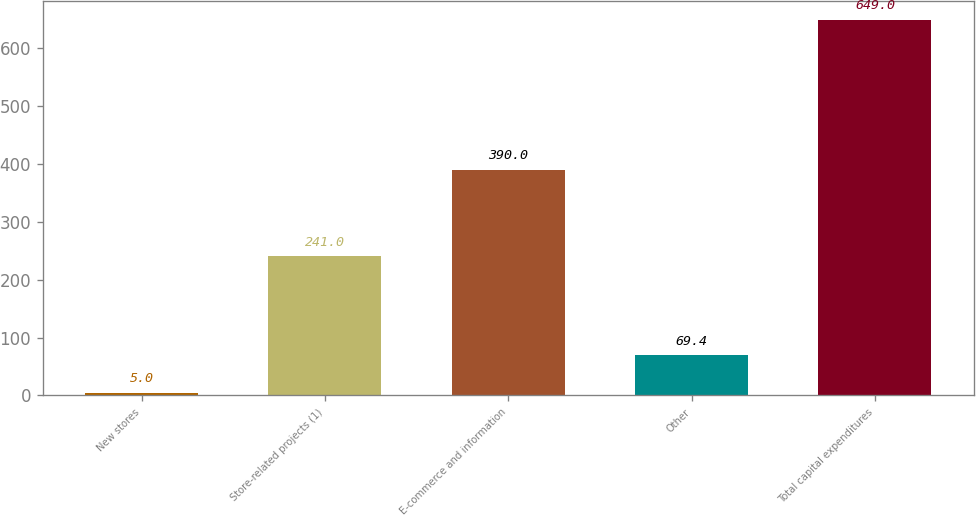<chart> <loc_0><loc_0><loc_500><loc_500><bar_chart><fcel>New stores<fcel>Store-related projects (1)<fcel>E-commerce and information<fcel>Other<fcel>Total capital expenditures<nl><fcel>5<fcel>241<fcel>390<fcel>69.4<fcel>649<nl></chart> 